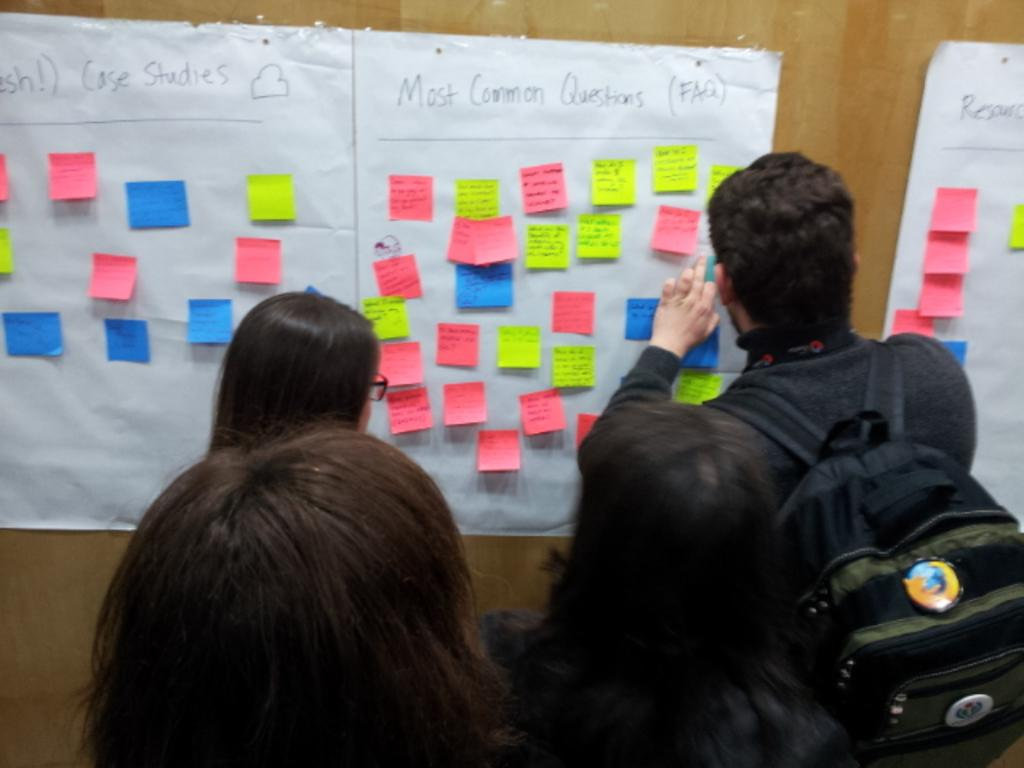How many people are in the image? There are people in the image, but the exact number is not specified. What is one person holding in the image? One person is holding something in the image, but the specific object is not described. What type of materials can be seen in the image? There are colorful papers in the image. What is attached to the brown surface in the image? Charts are attached to a brown surface in the image. What type of umbrella is being used by the friends in the image? There is no mention of an umbrella or friends in the image, so it cannot be determined if they are using an umbrella or not. What type of blade is being used by the person holding something in the image? There is no mention of a blade in the image, so it cannot be determined if someone is using a blade or not. 